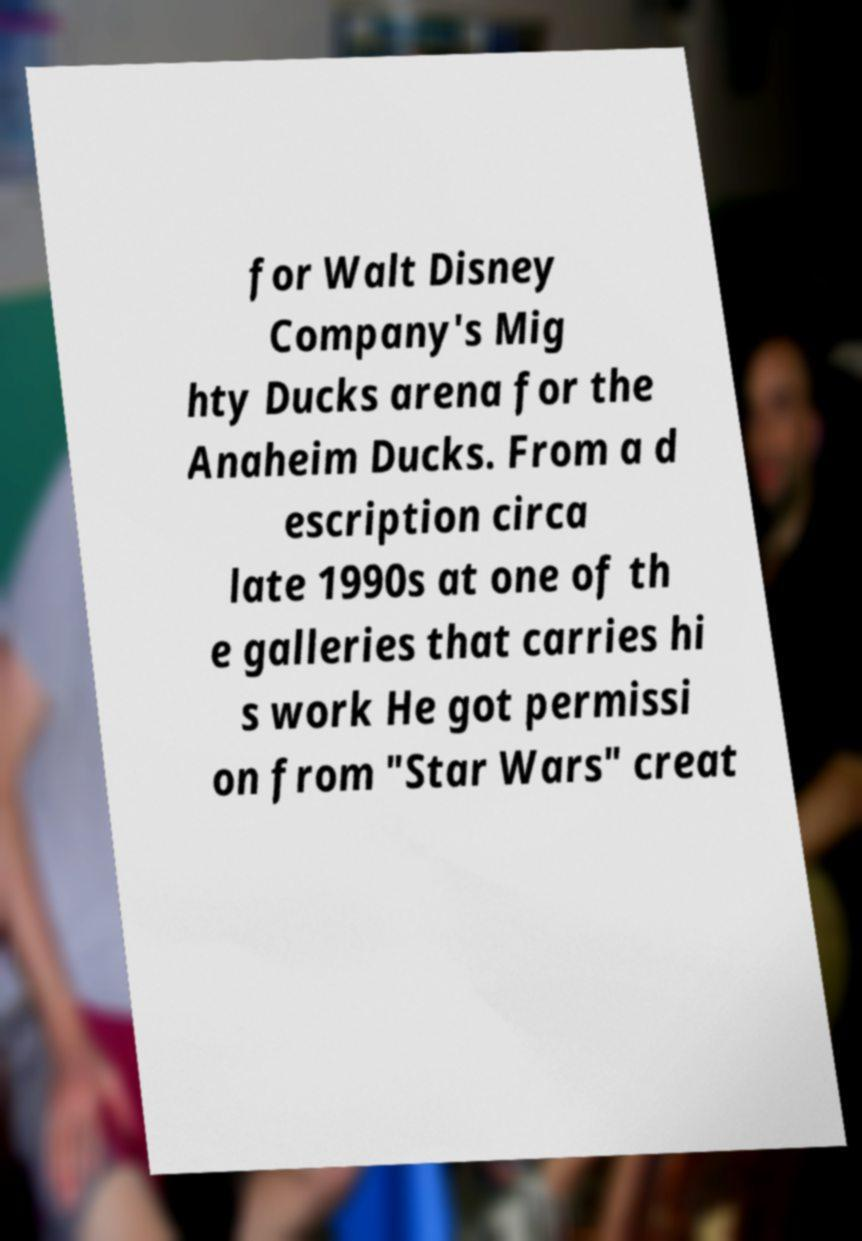I need the written content from this picture converted into text. Can you do that? for Walt Disney Company's Mig hty Ducks arena for the Anaheim Ducks. From a d escription circa late 1990s at one of th e galleries that carries hi s work He got permissi on from "Star Wars" creat 